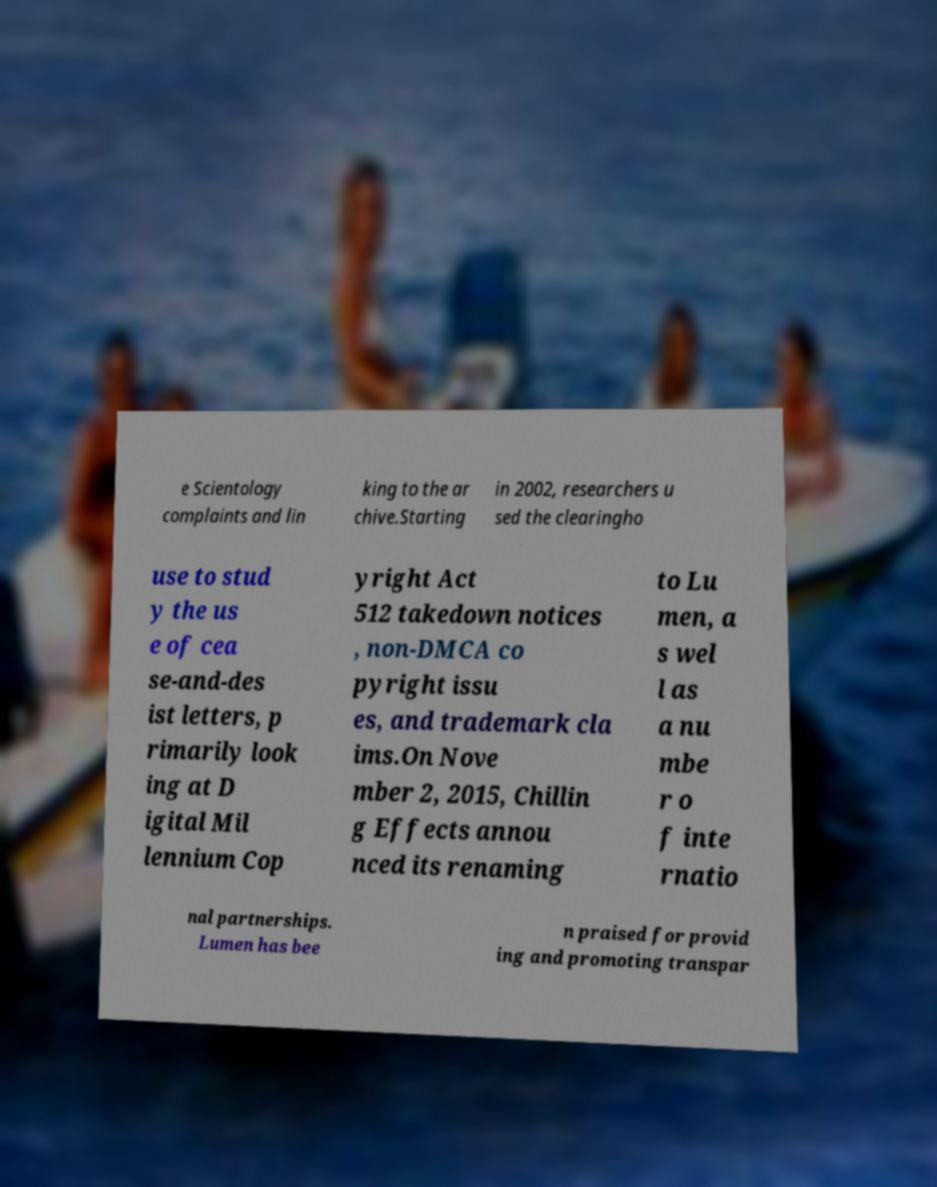Could you extract and type out the text from this image? e Scientology complaints and lin king to the ar chive.Starting in 2002, researchers u sed the clearingho use to stud y the us e of cea se-and-des ist letters, p rimarily look ing at D igital Mil lennium Cop yright Act 512 takedown notices , non-DMCA co pyright issu es, and trademark cla ims.On Nove mber 2, 2015, Chillin g Effects annou nced its renaming to Lu men, a s wel l as a nu mbe r o f inte rnatio nal partnerships. Lumen has bee n praised for provid ing and promoting transpar 